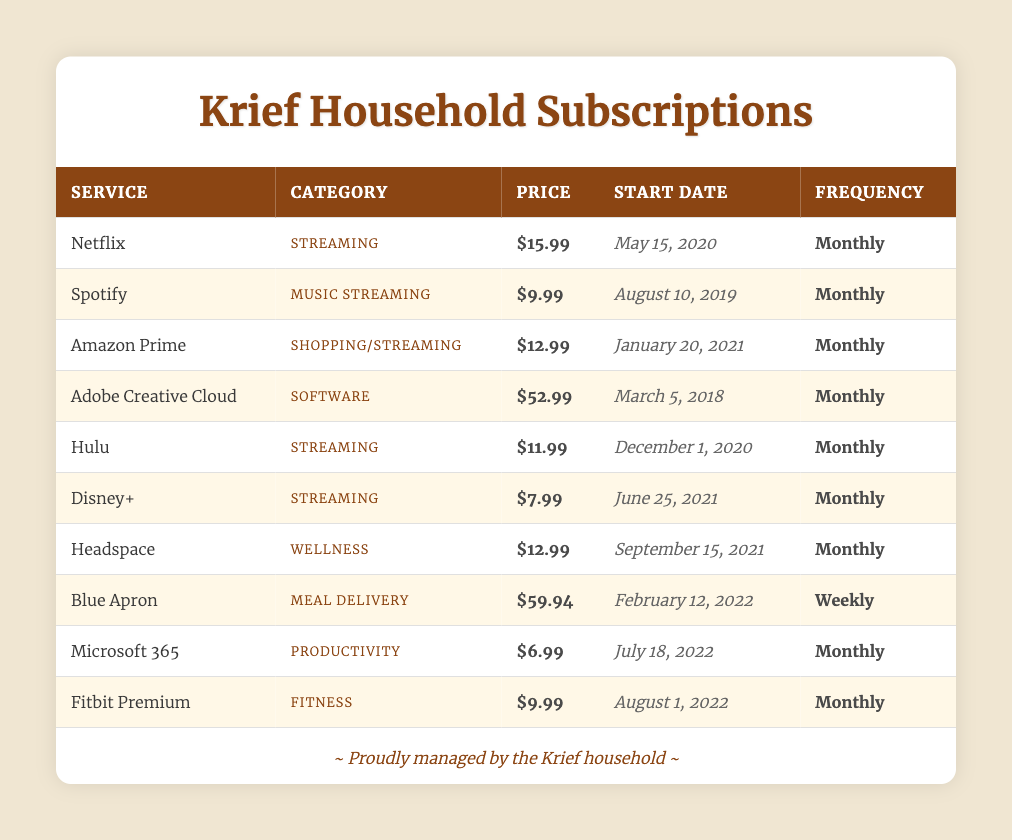What is the most expensive monthly subscription service in the Krief household? The table lists all the subscription services along with their prices. Scanning the prices, "Adobe Creative Cloud" has the highest price at $52.99.
Answer: Adobe Creative Cloud How many streaming services does the Krief household subscribe to? The table is examined for services with the category "Streaming." There are 5 services under this category: Netflix, Hulu, Disney+, and others.
Answer: 5 What is the total monthly cost of all subscription services used by the Krief household? To find the total, we sum all the monthly prices: 15.99 + 9.99 + 12.99 + 52.99 + 11.99 + 7.99 + 12.99 + 6.99 + 9.99 = $100.92.
Answer: $100.92 Which subscription service has been used the longest? Looking at the "Start Date" column, "Adobe Creative Cloud" started on March 5, 2018, which is the earliest among all services listed.
Answer: Adobe Creative Cloud Is the Krief household using any meal delivery services? By checking the table, we see that "Blue Apron" is listed under the "Meal Delivery" category, indicating they do use such a service.
Answer: Yes What is the average price of the monthly subscription services in the Krief household? The total monthly cost was computed previously as $100.92, and there are 9 services. So the average is calculated by dividing $100.92 by 9, resulting in approximately $11.22.
Answer: $11.22 Which service started in the year 2021 and is focused on wellness? By scanning the "Start Date" and "Category," we find "Headspace," which started on September 15, 2021, and falls under the "Wellness" category.
Answer: Headspace What category does the least expensive service belong to? After identifying that "Disney+" is $7.99, the category corresponding to this price is "Streaming."
Answer: Streaming How much more does the fitness subscription cost compared to the music streaming subscription? The prices are compared: "Fitbit Premium" costs $9.99, and "Spotify" costs $9.99 as well. The difference is $9.99 - $9.99 = $0.
Answer: $0 Are there any subscriptions that exceed $50 in monthly cost? The table is reviewed for any prices above $50 and confirms that "Adobe Creative Cloud" at $52.99 is the only one exceeding this amount.
Answer: Yes 